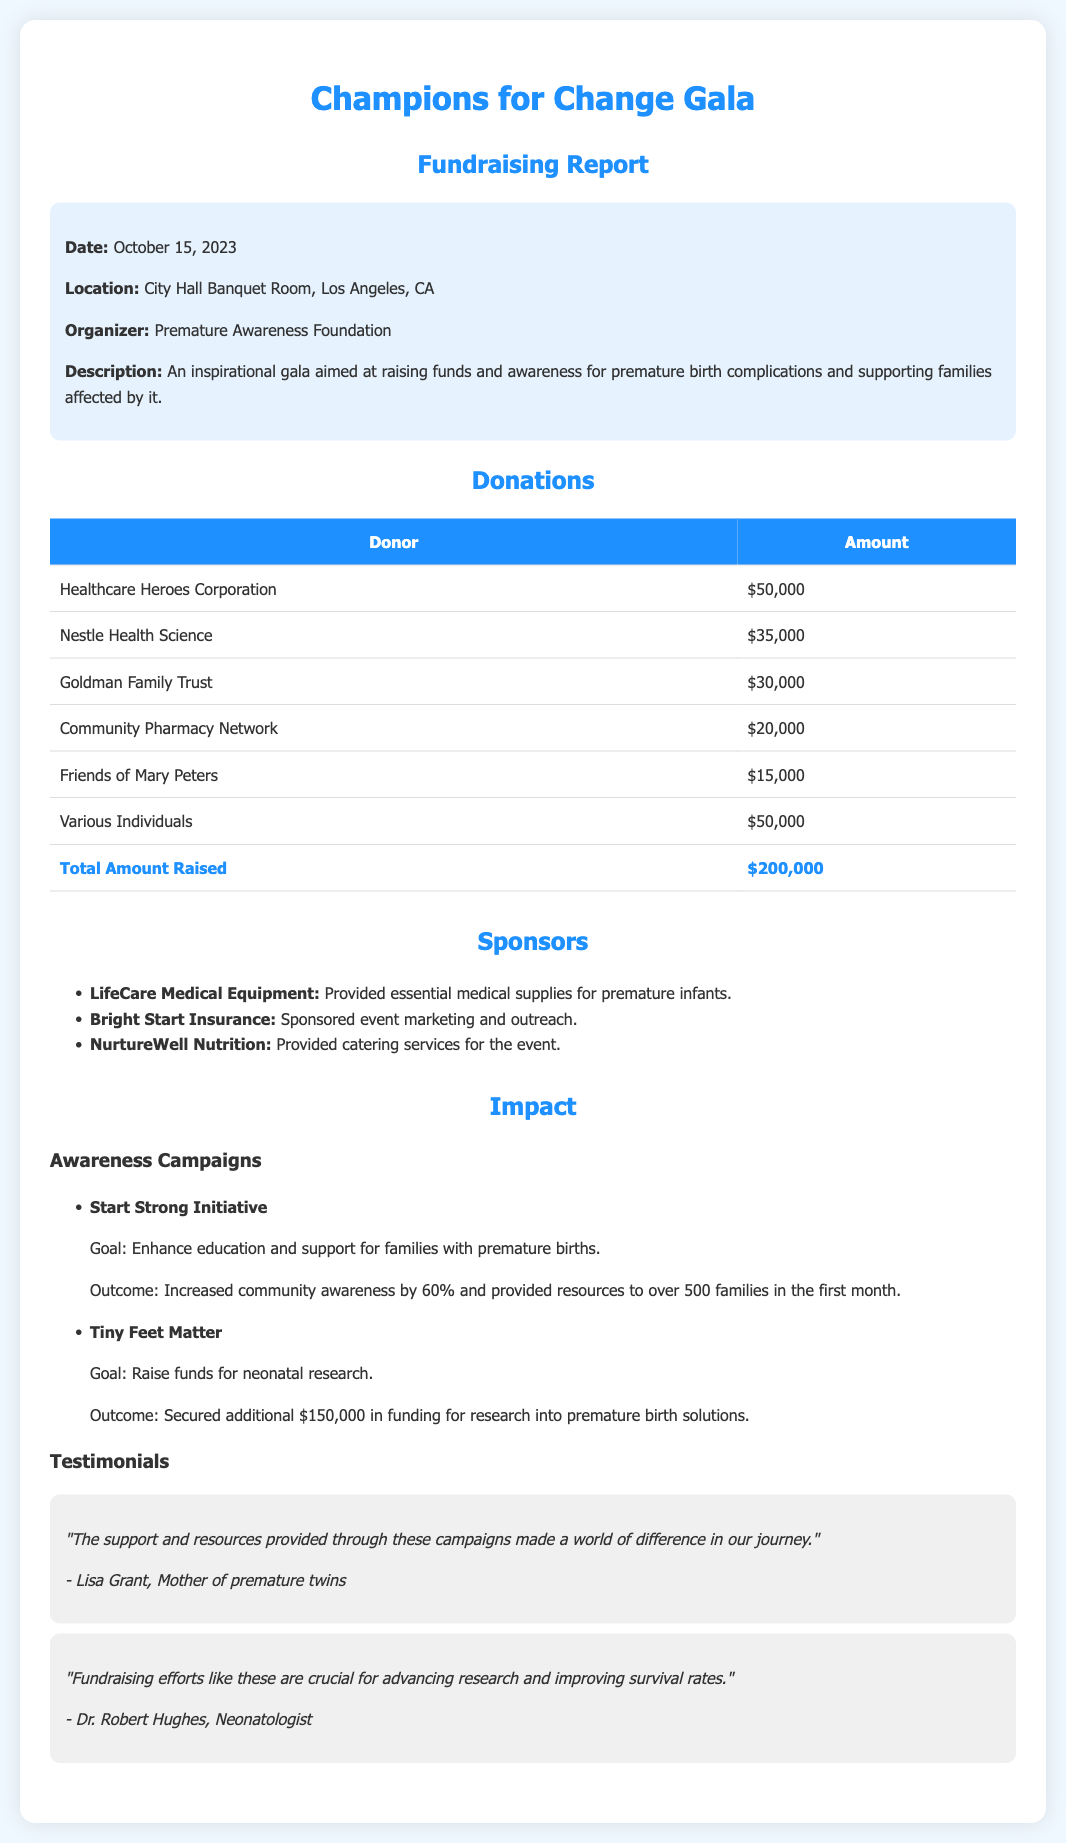what was the date of the event? The date of the event can be found in the event info section of the document.
Answer: October 15, 2023 how much did Healthcare Heroes Corporation donate? The donation amount from Healthcare Heroes Corporation is listed in the donations table.
Answer: $50,000 who organized the Champions for Change Gala? The organizer is mentioned directly in the event info section of the document.
Answer: Premature Awareness Foundation what is the total amount raised from the event? The total amount raised is summarized at the bottom of the donations table.
Answer: $200,000 what is the goal of the Start Strong Initiative? The goal of this initiative is described in the impact section of the document.
Answer: Enhance education and support for families with premature births how many families received resources from the Start Strong Initiative? The number of families that received resources is provided in the outcome section of the initiative.
Answer: 500 families which organization provided catering services for the event? The catering services provider is listed in the sponsors section of the document.
Answer: NurtureWell Nutrition what was the outcome of the Tiny Feet Matter campaign? The outcome is detailed under the impact section specifically related to this campaign.
Answer: Secured additional $150,000 in funding for research into premature birth solutions 